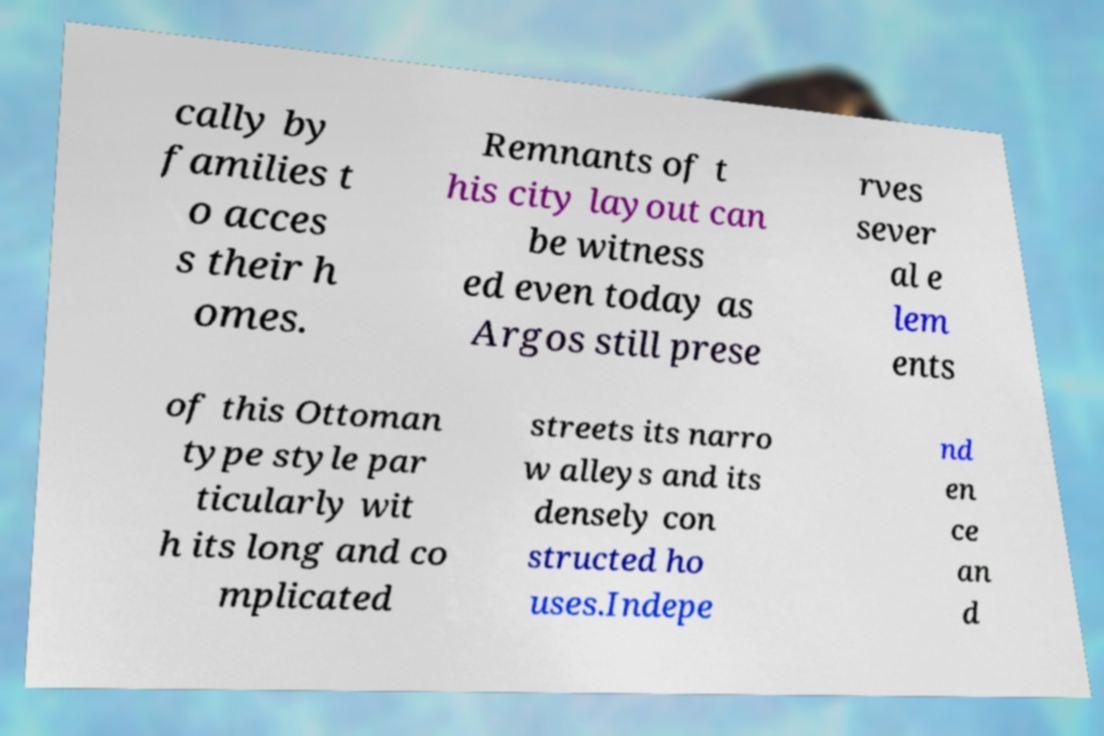Can you accurately transcribe the text from the provided image for me? cally by families t o acces s their h omes. Remnants of t his city layout can be witness ed even today as Argos still prese rves sever al e lem ents of this Ottoman type style par ticularly wit h its long and co mplicated streets its narro w alleys and its densely con structed ho uses.Indepe nd en ce an d 